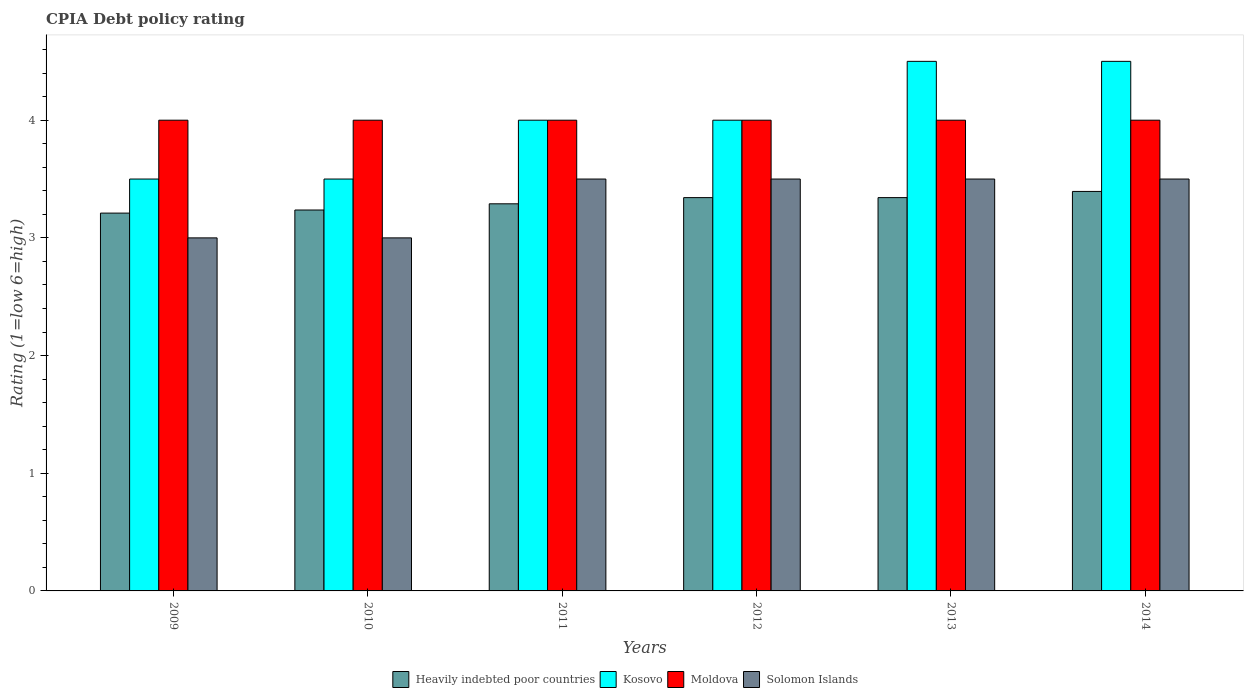How many different coloured bars are there?
Provide a succinct answer. 4. Are the number of bars on each tick of the X-axis equal?
Ensure brevity in your answer.  Yes. What is the label of the 3rd group of bars from the left?
Your answer should be very brief. 2011. What is the CPIA rating in Heavily indebted poor countries in 2014?
Offer a very short reply. 3.39. Across all years, what is the maximum CPIA rating in Moldova?
Make the answer very short. 4. In which year was the CPIA rating in Solomon Islands maximum?
Offer a very short reply. 2011. What is the total CPIA rating in Heavily indebted poor countries in the graph?
Ensure brevity in your answer.  19.82. What is the difference between the CPIA rating in Moldova in 2010 and the CPIA rating in Kosovo in 2012?
Your answer should be compact. 0. What is the average CPIA rating in Solomon Islands per year?
Keep it short and to the point. 3.33. What is the ratio of the CPIA rating in Heavily indebted poor countries in 2009 to that in 2010?
Your answer should be very brief. 0.99. Is the CPIA rating in Moldova in 2010 less than that in 2013?
Provide a succinct answer. No. What is the difference between the highest and the second highest CPIA rating in Moldova?
Provide a succinct answer. 0. What is the difference between the highest and the lowest CPIA rating in Solomon Islands?
Offer a terse response. 0.5. In how many years, is the CPIA rating in Kosovo greater than the average CPIA rating in Kosovo taken over all years?
Provide a short and direct response. 2. Is the sum of the CPIA rating in Solomon Islands in 2009 and 2014 greater than the maximum CPIA rating in Kosovo across all years?
Offer a terse response. Yes. Is it the case that in every year, the sum of the CPIA rating in Solomon Islands and CPIA rating in Heavily indebted poor countries is greater than the sum of CPIA rating in Kosovo and CPIA rating in Moldova?
Your response must be concise. No. What does the 1st bar from the left in 2009 represents?
Offer a terse response. Heavily indebted poor countries. What does the 1st bar from the right in 2013 represents?
Your answer should be very brief. Solomon Islands. Is it the case that in every year, the sum of the CPIA rating in Solomon Islands and CPIA rating in Heavily indebted poor countries is greater than the CPIA rating in Kosovo?
Your answer should be compact. Yes. How many bars are there?
Offer a terse response. 24. Are all the bars in the graph horizontal?
Give a very brief answer. No. How many years are there in the graph?
Keep it short and to the point. 6. What is the difference between two consecutive major ticks on the Y-axis?
Keep it short and to the point. 1. Does the graph contain any zero values?
Provide a succinct answer. No. Where does the legend appear in the graph?
Make the answer very short. Bottom center. How many legend labels are there?
Provide a succinct answer. 4. What is the title of the graph?
Your answer should be compact. CPIA Debt policy rating. What is the label or title of the Y-axis?
Offer a very short reply. Rating (1=low 6=high). What is the Rating (1=low 6=high) in Heavily indebted poor countries in 2009?
Your answer should be compact. 3.21. What is the Rating (1=low 6=high) of Moldova in 2009?
Your response must be concise. 4. What is the Rating (1=low 6=high) in Heavily indebted poor countries in 2010?
Offer a terse response. 3.24. What is the Rating (1=low 6=high) of Kosovo in 2010?
Offer a terse response. 3.5. What is the Rating (1=low 6=high) in Solomon Islands in 2010?
Offer a terse response. 3. What is the Rating (1=low 6=high) of Heavily indebted poor countries in 2011?
Give a very brief answer. 3.29. What is the Rating (1=low 6=high) in Solomon Islands in 2011?
Your answer should be compact. 3.5. What is the Rating (1=low 6=high) of Heavily indebted poor countries in 2012?
Give a very brief answer. 3.34. What is the Rating (1=low 6=high) of Solomon Islands in 2012?
Offer a very short reply. 3.5. What is the Rating (1=low 6=high) of Heavily indebted poor countries in 2013?
Provide a short and direct response. 3.34. What is the Rating (1=low 6=high) of Heavily indebted poor countries in 2014?
Give a very brief answer. 3.39. What is the Rating (1=low 6=high) in Moldova in 2014?
Offer a terse response. 4. What is the Rating (1=low 6=high) of Solomon Islands in 2014?
Keep it short and to the point. 3.5. Across all years, what is the maximum Rating (1=low 6=high) in Heavily indebted poor countries?
Your response must be concise. 3.39. Across all years, what is the maximum Rating (1=low 6=high) in Kosovo?
Keep it short and to the point. 4.5. Across all years, what is the maximum Rating (1=low 6=high) of Solomon Islands?
Ensure brevity in your answer.  3.5. Across all years, what is the minimum Rating (1=low 6=high) of Heavily indebted poor countries?
Keep it short and to the point. 3.21. What is the total Rating (1=low 6=high) in Heavily indebted poor countries in the graph?
Offer a terse response. 19.82. What is the total Rating (1=low 6=high) of Solomon Islands in the graph?
Make the answer very short. 20. What is the difference between the Rating (1=low 6=high) of Heavily indebted poor countries in 2009 and that in 2010?
Offer a very short reply. -0.03. What is the difference between the Rating (1=low 6=high) of Kosovo in 2009 and that in 2010?
Your answer should be compact. 0. What is the difference between the Rating (1=low 6=high) of Moldova in 2009 and that in 2010?
Keep it short and to the point. 0. What is the difference between the Rating (1=low 6=high) in Heavily indebted poor countries in 2009 and that in 2011?
Keep it short and to the point. -0.08. What is the difference between the Rating (1=low 6=high) in Moldova in 2009 and that in 2011?
Give a very brief answer. 0. What is the difference between the Rating (1=low 6=high) in Heavily indebted poor countries in 2009 and that in 2012?
Give a very brief answer. -0.13. What is the difference between the Rating (1=low 6=high) in Solomon Islands in 2009 and that in 2012?
Your answer should be very brief. -0.5. What is the difference between the Rating (1=low 6=high) in Heavily indebted poor countries in 2009 and that in 2013?
Your answer should be very brief. -0.13. What is the difference between the Rating (1=low 6=high) in Moldova in 2009 and that in 2013?
Your response must be concise. 0. What is the difference between the Rating (1=low 6=high) of Solomon Islands in 2009 and that in 2013?
Make the answer very short. -0.5. What is the difference between the Rating (1=low 6=high) in Heavily indebted poor countries in 2009 and that in 2014?
Provide a short and direct response. -0.18. What is the difference between the Rating (1=low 6=high) in Solomon Islands in 2009 and that in 2014?
Your response must be concise. -0.5. What is the difference between the Rating (1=low 6=high) in Heavily indebted poor countries in 2010 and that in 2011?
Provide a succinct answer. -0.05. What is the difference between the Rating (1=low 6=high) in Kosovo in 2010 and that in 2011?
Give a very brief answer. -0.5. What is the difference between the Rating (1=low 6=high) of Heavily indebted poor countries in 2010 and that in 2012?
Ensure brevity in your answer.  -0.11. What is the difference between the Rating (1=low 6=high) in Solomon Islands in 2010 and that in 2012?
Give a very brief answer. -0.5. What is the difference between the Rating (1=low 6=high) in Heavily indebted poor countries in 2010 and that in 2013?
Offer a very short reply. -0.11. What is the difference between the Rating (1=low 6=high) of Kosovo in 2010 and that in 2013?
Provide a succinct answer. -1. What is the difference between the Rating (1=low 6=high) in Heavily indebted poor countries in 2010 and that in 2014?
Make the answer very short. -0.16. What is the difference between the Rating (1=low 6=high) in Kosovo in 2010 and that in 2014?
Offer a very short reply. -1. What is the difference between the Rating (1=low 6=high) in Moldova in 2010 and that in 2014?
Ensure brevity in your answer.  0. What is the difference between the Rating (1=low 6=high) of Solomon Islands in 2010 and that in 2014?
Provide a succinct answer. -0.5. What is the difference between the Rating (1=low 6=high) in Heavily indebted poor countries in 2011 and that in 2012?
Offer a very short reply. -0.05. What is the difference between the Rating (1=low 6=high) of Moldova in 2011 and that in 2012?
Your response must be concise. 0. What is the difference between the Rating (1=low 6=high) of Heavily indebted poor countries in 2011 and that in 2013?
Your answer should be very brief. -0.05. What is the difference between the Rating (1=low 6=high) of Kosovo in 2011 and that in 2013?
Offer a terse response. -0.5. What is the difference between the Rating (1=low 6=high) in Heavily indebted poor countries in 2011 and that in 2014?
Offer a terse response. -0.11. What is the difference between the Rating (1=low 6=high) of Kosovo in 2011 and that in 2014?
Keep it short and to the point. -0.5. What is the difference between the Rating (1=low 6=high) in Moldova in 2011 and that in 2014?
Provide a short and direct response. 0. What is the difference between the Rating (1=low 6=high) of Kosovo in 2012 and that in 2013?
Offer a terse response. -0.5. What is the difference between the Rating (1=low 6=high) of Heavily indebted poor countries in 2012 and that in 2014?
Make the answer very short. -0.05. What is the difference between the Rating (1=low 6=high) of Solomon Islands in 2012 and that in 2014?
Offer a very short reply. 0. What is the difference between the Rating (1=low 6=high) in Heavily indebted poor countries in 2013 and that in 2014?
Your answer should be very brief. -0.05. What is the difference between the Rating (1=low 6=high) in Moldova in 2013 and that in 2014?
Make the answer very short. 0. What is the difference between the Rating (1=low 6=high) in Solomon Islands in 2013 and that in 2014?
Your response must be concise. 0. What is the difference between the Rating (1=low 6=high) of Heavily indebted poor countries in 2009 and the Rating (1=low 6=high) of Kosovo in 2010?
Provide a succinct answer. -0.29. What is the difference between the Rating (1=low 6=high) in Heavily indebted poor countries in 2009 and the Rating (1=low 6=high) in Moldova in 2010?
Provide a succinct answer. -0.79. What is the difference between the Rating (1=low 6=high) of Heavily indebted poor countries in 2009 and the Rating (1=low 6=high) of Solomon Islands in 2010?
Your response must be concise. 0.21. What is the difference between the Rating (1=low 6=high) in Kosovo in 2009 and the Rating (1=low 6=high) in Solomon Islands in 2010?
Make the answer very short. 0.5. What is the difference between the Rating (1=low 6=high) in Moldova in 2009 and the Rating (1=low 6=high) in Solomon Islands in 2010?
Ensure brevity in your answer.  1. What is the difference between the Rating (1=low 6=high) of Heavily indebted poor countries in 2009 and the Rating (1=low 6=high) of Kosovo in 2011?
Offer a very short reply. -0.79. What is the difference between the Rating (1=low 6=high) in Heavily indebted poor countries in 2009 and the Rating (1=low 6=high) in Moldova in 2011?
Give a very brief answer. -0.79. What is the difference between the Rating (1=low 6=high) of Heavily indebted poor countries in 2009 and the Rating (1=low 6=high) of Solomon Islands in 2011?
Provide a succinct answer. -0.29. What is the difference between the Rating (1=low 6=high) of Kosovo in 2009 and the Rating (1=low 6=high) of Moldova in 2011?
Ensure brevity in your answer.  -0.5. What is the difference between the Rating (1=low 6=high) of Moldova in 2009 and the Rating (1=low 6=high) of Solomon Islands in 2011?
Provide a short and direct response. 0.5. What is the difference between the Rating (1=low 6=high) of Heavily indebted poor countries in 2009 and the Rating (1=low 6=high) of Kosovo in 2012?
Keep it short and to the point. -0.79. What is the difference between the Rating (1=low 6=high) in Heavily indebted poor countries in 2009 and the Rating (1=low 6=high) in Moldova in 2012?
Your answer should be compact. -0.79. What is the difference between the Rating (1=low 6=high) of Heavily indebted poor countries in 2009 and the Rating (1=low 6=high) of Solomon Islands in 2012?
Ensure brevity in your answer.  -0.29. What is the difference between the Rating (1=low 6=high) in Kosovo in 2009 and the Rating (1=low 6=high) in Moldova in 2012?
Give a very brief answer. -0.5. What is the difference between the Rating (1=low 6=high) in Heavily indebted poor countries in 2009 and the Rating (1=low 6=high) in Kosovo in 2013?
Ensure brevity in your answer.  -1.29. What is the difference between the Rating (1=low 6=high) of Heavily indebted poor countries in 2009 and the Rating (1=low 6=high) of Moldova in 2013?
Give a very brief answer. -0.79. What is the difference between the Rating (1=low 6=high) of Heavily indebted poor countries in 2009 and the Rating (1=low 6=high) of Solomon Islands in 2013?
Make the answer very short. -0.29. What is the difference between the Rating (1=low 6=high) in Kosovo in 2009 and the Rating (1=low 6=high) in Moldova in 2013?
Offer a very short reply. -0.5. What is the difference between the Rating (1=low 6=high) in Heavily indebted poor countries in 2009 and the Rating (1=low 6=high) in Kosovo in 2014?
Offer a terse response. -1.29. What is the difference between the Rating (1=low 6=high) of Heavily indebted poor countries in 2009 and the Rating (1=low 6=high) of Moldova in 2014?
Provide a succinct answer. -0.79. What is the difference between the Rating (1=low 6=high) of Heavily indebted poor countries in 2009 and the Rating (1=low 6=high) of Solomon Islands in 2014?
Keep it short and to the point. -0.29. What is the difference between the Rating (1=low 6=high) in Kosovo in 2009 and the Rating (1=low 6=high) in Moldova in 2014?
Offer a terse response. -0.5. What is the difference between the Rating (1=low 6=high) of Moldova in 2009 and the Rating (1=low 6=high) of Solomon Islands in 2014?
Your response must be concise. 0.5. What is the difference between the Rating (1=low 6=high) in Heavily indebted poor countries in 2010 and the Rating (1=low 6=high) in Kosovo in 2011?
Offer a very short reply. -0.76. What is the difference between the Rating (1=low 6=high) of Heavily indebted poor countries in 2010 and the Rating (1=low 6=high) of Moldova in 2011?
Provide a succinct answer. -0.76. What is the difference between the Rating (1=low 6=high) of Heavily indebted poor countries in 2010 and the Rating (1=low 6=high) of Solomon Islands in 2011?
Ensure brevity in your answer.  -0.26. What is the difference between the Rating (1=low 6=high) in Moldova in 2010 and the Rating (1=low 6=high) in Solomon Islands in 2011?
Make the answer very short. 0.5. What is the difference between the Rating (1=low 6=high) of Heavily indebted poor countries in 2010 and the Rating (1=low 6=high) of Kosovo in 2012?
Keep it short and to the point. -0.76. What is the difference between the Rating (1=low 6=high) in Heavily indebted poor countries in 2010 and the Rating (1=low 6=high) in Moldova in 2012?
Keep it short and to the point. -0.76. What is the difference between the Rating (1=low 6=high) of Heavily indebted poor countries in 2010 and the Rating (1=low 6=high) of Solomon Islands in 2012?
Provide a short and direct response. -0.26. What is the difference between the Rating (1=low 6=high) of Kosovo in 2010 and the Rating (1=low 6=high) of Moldova in 2012?
Make the answer very short. -0.5. What is the difference between the Rating (1=low 6=high) of Heavily indebted poor countries in 2010 and the Rating (1=low 6=high) of Kosovo in 2013?
Give a very brief answer. -1.26. What is the difference between the Rating (1=low 6=high) in Heavily indebted poor countries in 2010 and the Rating (1=low 6=high) in Moldova in 2013?
Your answer should be very brief. -0.76. What is the difference between the Rating (1=low 6=high) of Heavily indebted poor countries in 2010 and the Rating (1=low 6=high) of Solomon Islands in 2013?
Make the answer very short. -0.26. What is the difference between the Rating (1=low 6=high) of Kosovo in 2010 and the Rating (1=low 6=high) of Moldova in 2013?
Provide a short and direct response. -0.5. What is the difference between the Rating (1=low 6=high) of Moldova in 2010 and the Rating (1=low 6=high) of Solomon Islands in 2013?
Ensure brevity in your answer.  0.5. What is the difference between the Rating (1=low 6=high) of Heavily indebted poor countries in 2010 and the Rating (1=low 6=high) of Kosovo in 2014?
Your answer should be very brief. -1.26. What is the difference between the Rating (1=low 6=high) in Heavily indebted poor countries in 2010 and the Rating (1=low 6=high) in Moldova in 2014?
Offer a terse response. -0.76. What is the difference between the Rating (1=low 6=high) in Heavily indebted poor countries in 2010 and the Rating (1=low 6=high) in Solomon Islands in 2014?
Offer a very short reply. -0.26. What is the difference between the Rating (1=low 6=high) in Kosovo in 2010 and the Rating (1=low 6=high) in Moldova in 2014?
Make the answer very short. -0.5. What is the difference between the Rating (1=low 6=high) in Kosovo in 2010 and the Rating (1=low 6=high) in Solomon Islands in 2014?
Make the answer very short. 0. What is the difference between the Rating (1=low 6=high) of Heavily indebted poor countries in 2011 and the Rating (1=low 6=high) of Kosovo in 2012?
Keep it short and to the point. -0.71. What is the difference between the Rating (1=low 6=high) in Heavily indebted poor countries in 2011 and the Rating (1=low 6=high) in Moldova in 2012?
Your answer should be very brief. -0.71. What is the difference between the Rating (1=low 6=high) of Heavily indebted poor countries in 2011 and the Rating (1=low 6=high) of Solomon Islands in 2012?
Your answer should be very brief. -0.21. What is the difference between the Rating (1=low 6=high) of Moldova in 2011 and the Rating (1=low 6=high) of Solomon Islands in 2012?
Give a very brief answer. 0.5. What is the difference between the Rating (1=low 6=high) of Heavily indebted poor countries in 2011 and the Rating (1=low 6=high) of Kosovo in 2013?
Keep it short and to the point. -1.21. What is the difference between the Rating (1=low 6=high) in Heavily indebted poor countries in 2011 and the Rating (1=low 6=high) in Moldova in 2013?
Offer a terse response. -0.71. What is the difference between the Rating (1=low 6=high) of Heavily indebted poor countries in 2011 and the Rating (1=low 6=high) of Solomon Islands in 2013?
Ensure brevity in your answer.  -0.21. What is the difference between the Rating (1=low 6=high) in Kosovo in 2011 and the Rating (1=low 6=high) in Moldova in 2013?
Provide a short and direct response. 0. What is the difference between the Rating (1=low 6=high) of Moldova in 2011 and the Rating (1=low 6=high) of Solomon Islands in 2013?
Make the answer very short. 0.5. What is the difference between the Rating (1=low 6=high) of Heavily indebted poor countries in 2011 and the Rating (1=low 6=high) of Kosovo in 2014?
Your answer should be very brief. -1.21. What is the difference between the Rating (1=low 6=high) in Heavily indebted poor countries in 2011 and the Rating (1=low 6=high) in Moldova in 2014?
Provide a succinct answer. -0.71. What is the difference between the Rating (1=low 6=high) of Heavily indebted poor countries in 2011 and the Rating (1=low 6=high) of Solomon Islands in 2014?
Your answer should be compact. -0.21. What is the difference between the Rating (1=low 6=high) in Kosovo in 2011 and the Rating (1=low 6=high) in Solomon Islands in 2014?
Give a very brief answer. 0.5. What is the difference between the Rating (1=low 6=high) in Heavily indebted poor countries in 2012 and the Rating (1=low 6=high) in Kosovo in 2013?
Keep it short and to the point. -1.16. What is the difference between the Rating (1=low 6=high) of Heavily indebted poor countries in 2012 and the Rating (1=low 6=high) of Moldova in 2013?
Your answer should be compact. -0.66. What is the difference between the Rating (1=low 6=high) in Heavily indebted poor countries in 2012 and the Rating (1=low 6=high) in Solomon Islands in 2013?
Offer a very short reply. -0.16. What is the difference between the Rating (1=low 6=high) of Kosovo in 2012 and the Rating (1=low 6=high) of Solomon Islands in 2013?
Your response must be concise. 0.5. What is the difference between the Rating (1=low 6=high) in Moldova in 2012 and the Rating (1=low 6=high) in Solomon Islands in 2013?
Make the answer very short. 0.5. What is the difference between the Rating (1=low 6=high) in Heavily indebted poor countries in 2012 and the Rating (1=low 6=high) in Kosovo in 2014?
Ensure brevity in your answer.  -1.16. What is the difference between the Rating (1=low 6=high) of Heavily indebted poor countries in 2012 and the Rating (1=low 6=high) of Moldova in 2014?
Provide a succinct answer. -0.66. What is the difference between the Rating (1=low 6=high) in Heavily indebted poor countries in 2012 and the Rating (1=low 6=high) in Solomon Islands in 2014?
Provide a short and direct response. -0.16. What is the difference between the Rating (1=low 6=high) of Kosovo in 2012 and the Rating (1=low 6=high) of Moldova in 2014?
Ensure brevity in your answer.  0. What is the difference between the Rating (1=low 6=high) of Kosovo in 2012 and the Rating (1=low 6=high) of Solomon Islands in 2014?
Your response must be concise. 0.5. What is the difference between the Rating (1=low 6=high) in Moldova in 2012 and the Rating (1=low 6=high) in Solomon Islands in 2014?
Make the answer very short. 0.5. What is the difference between the Rating (1=low 6=high) of Heavily indebted poor countries in 2013 and the Rating (1=low 6=high) of Kosovo in 2014?
Keep it short and to the point. -1.16. What is the difference between the Rating (1=low 6=high) of Heavily indebted poor countries in 2013 and the Rating (1=low 6=high) of Moldova in 2014?
Ensure brevity in your answer.  -0.66. What is the difference between the Rating (1=low 6=high) in Heavily indebted poor countries in 2013 and the Rating (1=low 6=high) in Solomon Islands in 2014?
Give a very brief answer. -0.16. What is the difference between the Rating (1=low 6=high) of Kosovo in 2013 and the Rating (1=low 6=high) of Moldova in 2014?
Make the answer very short. 0.5. What is the average Rating (1=low 6=high) of Heavily indebted poor countries per year?
Keep it short and to the point. 3.3. What is the average Rating (1=low 6=high) of Moldova per year?
Your response must be concise. 4. In the year 2009, what is the difference between the Rating (1=low 6=high) in Heavily indebted poor countries and Rating (1=low 6=high) in Kosovo?
Give a very brief answer. -0.29. In the year 2009, what is the difference between the Rating (1=low 6=high) of Heavily indebted poor countries and Rating (1=low 6=high) of Moldova?
Offer a terse response. -0.79. In the year 2009, what is the difference between the Rating (1=low 6=high) in Heavily indebted poor countries and Rating (1=low 6=high) in Solomon Islands?
Your answer should be very brief. 0.21. In the year 2009, what is the difference between the Rating (1=low 6=high) of Kosovo and Rating (1=low 6=high) of Solomon Islands?
Offer a terse response. 0.5. In the year 2009, what is the difference between the Rating (1=low 6=high) of Moldova and Rating (1=low 6=high) of Solomon Islands?
Keep it short and to the point. 1. In the year 2010, what is the difference between the Rating (1=low 6=high) in Heavily indebted poor countries and Rating (1=low 6=high) in Kosovo?
Keep it short and to the point. -0.26. In the year 2010, what is the difference between the Rating (1=low 6=high) in Heavily indebted poor countries and Rating (1=low 6=high) in Moldova?
Your answer should be compact. -0.76. In the year 2010, what is the difference between the Rating (1=low 6=high) in Heavily indebted poor countries and Rating (1=low 6=high) in Solomon Islands?
Your answer should be compact. 0.24. In the year 2010, what is the difference between the Rating (1=low 6=high) in Moldova and Rating (1=low 6=high) in Solomon Islands?
Your answer should be very brief. 1. In the year 2011, what is the difference between the Rating (1=low 6=high) of Heavily indebted poor countries and Rating (1=low 6=high) of Kosovo?
Your answer should be very brief. -0.71. In the year 2011, what is the difference between the Rating (1=low 6=high) of Heavily indebted poor countries and Rating (1=low 6=high) of Moldova?
Offer a very short reply. -0.71. In the year 2011, what is the difference between the Rating (1=low 6=high) in Heavily indebted poor countries and Rating (1=low 6=high) in Solomon Islands?
Make the answer very short. -0.21. In the year 2011, what is the difference between the Rating (1=low 6=high) in Kosovo and Rating (1=low 6=high) in Moldova?
Ensure brevity in your answer.  0. In the year 2012, what is the difference between the Rating (1=low 6=high) in Heavily indebted poor countries and Rating (1=low 6=high) in Kosovo?
Offer a very short reply. -0.66. In the year 2012, what is the difference between the Rating (1=low 6=high) of Heavily indebted poor countries and Rating (1=low 6=high) of Moldova?
Provide a short and direct response. -0.66. In the year 2012, what is the difference between the Rating (1=low 6=high) of Heavily indebted poor countries and Rating (1=low 6=high) of Solomon Islands?
Offer a terse response. -0.16. In the year 2012, what is the difference between the Rating (1=low 6=high) of Kosovo and Rating (1=low 6=high) of Moldova?
Provide a short and direct response. 0. In the year 2012, what is the difference between the Rating (1=low 6=high) of Moldova and Rating (1=low 6=high) of Solomon Islands?
Provide a short and direct response. 0.5. In the year 2013, what is the difference between the Rating (1=low 6=high) in Heavily indebted poor countries and Rating (1=low 6=high) in Kosovo?
Provide a short and direct response. -1.16. In the year 2013, what is the difference between the Rating (1=low 6=high) in Heavily indebted poor countries and Rating (1=low 6=high) in Moldova?
Your response must be concise. -0.66. In the year 2013, what is the difference between the Rating (1=low 6=high) in Heavily indebted poor countries and Rating (1=low 6=high) in Solomon Islands?
Offer a very short reply. -0.16. In the year 2013, what is the difference between the Rating (1=low 6=high) in Kosovo and Rating (1=low 6=high) in Solomon Islands?
Ensure brevity in your answer.  1. In the year 2013, what is the difference between the Rating (1=low 6=high) in Moldova and Rating (1=low 6=high) in Solomon Islands?
Provide a short and direct response. 0.5. In the year 2014, what is the difference between the Rating (1=low 6=high) in Heavily indebted poor countries and Rating (1=low 6=high) in Kosovo?
Offer a terse response. -1.11. In the year 2014, what is the difference between the Rating (1=low 6=high) of Heavily indebted poor countries and Rating (1=low 6=high) of Moldova?
Your answer should be very brief. -0.61. In the year 2014, what is the difference between the Rating (1=low 6=high) of Heavily indebted poor countries and Rating (1=low 6=high) of Solomon Islands?
Provide a short and direct response. -0.11. In the year 2014, what is the difference between the Rating (1=low 6=high) in Moldova and Rating (1=low 6=high) in Solomon Islands?
Ensure brevity in your answer.  0.5. What is the ratio of the Rating (1=low 6=high) of Heavily indebted poor countries in 2009 to that in 2010?
Offer a terse response. 0.99. What is the ratio of the Rating (1=low 6=high) in Moldova in 2009 to that in 2010?
Keep it short and to the point. 1. What is the ratio of the Rating (1=low 6=high) in Solomon Islands in 2009 to that in 2010?
Give a very brief answer. 1. What is the ratio of the Rating (1=low 6=high) of Heavily indebted poor countries in 2009 to that in 2011?
Ensure brevity in your answer.  0.98. What is the ratio of the Rating (1=low 6=high) in Kosovo in 2009 to that in 2011?
Your answer should be very brief. 0.88. What is the ratio of the Rating (1=low 6=high) of Solomon Islands in 2009 to that in 2011?
Make the answer very short. 0.86. What is the ratio of the Rating (1=low 6=high) of Heavily indebted poor countries in 2009 to that in 2012?
Provide a short and direct response. 0.96. What is the ratio of the Rating (1=low 6=high) of Heavily indebted poor countries in 2009 to that in 2013?
Your answer should be very brief. 0.96. What is the ratio of the Rating (1=low 6=high) of Kosovo in 2009 to that in 2013?
Offer a terse response. 0.78. What is the ratio of the Rating (1=low 6=high) in Moldova in 2009 to that in 2013?
Your answer should be compact. 1. What is the ratio of the Rating (1=low 6=high) in Solomon Islands in 2009 to that in 2013?
Provide a short and direct response. 0.86. What is the ratio of the Rating (1=low 6=high) of Heavily indebted poor countries in 2009 to that in 2014?
Your answer should be very brief. 0.95. What is the ratio of the Rating (1=low 6=high) in Heavily indebted poor countries in 2010 to that in 2011?
Keep it short and to the point. 0.98. What is the ratio of the Rating (1=low 6=high) in Kosovo in 2010 to that in 2011?
Ensure brevity in your answer.  0.88. What is the ratio of the Rating (1=low 6=high) in Moldova in 2010 to that in 2011?
Give a very brief answer. 1. What is the ratio of the Rating (1=low 6=high) of Heavily indebted poor countries in 2010 to that in 2012?
Give a very brief answer. 0.97. What is the ratio of the Rating (1=low 6=high) of Moldova in 2010 to that in 2012?
Keep it short and to the point. 1. What is the ratio of the Rating (1=low 6=high) of Heavily indebted poor countries in 2010 to that in 2013?
Your answer should be compact. 0.97. What is the ratio of the Rating (1=low 6=high) of Kosovo in 2010 to that in 2013?
Ensure brevity in your answer.  0.78. What is the ratio of the Rating (1=low 6=high) in Heavily indebted poor countries in 2010 to that in 2014?
Give a very brief answer. 0.95. What is the ratio of the Rating (1=low 6=high) of Moldova in 2010 to that in 2014?
Provide a short and direct response. 1. What is the ratio of the Rating (1=low 6=high) in Solomon Islands in 2010 to that in 2014?
Your response must be concise. 0.86. What is the ratio of the Rating (1=low 6=high) in Heavily indebted poor countries in 2011 to that in 2012?
Ensure brevity in your answer.  0.98. What is the ratio of the Rating (1=low 6=high) of Kosovo in 2011 to that in 2012?
Your answer should be compact. 1. What is the ratio of the Rating (1=low 6=high) of Solomon Islands in 2011 to that in 2012?
Offer a terse response. 1. What is the ratio of the Rating (1=low 6=high) in Heavily indebted poor countries in 2011 to that in 2013?
Your response must be concise. 0.98. What is the ratio of the Rating (1=low 6=high) of Moldova in 2011 to that in 2013?
Ensure brevity in your answer.  1. What is the ratio of the Rating (1=low 6=high) in Solomon Islands in 2011 to that in 2013?
Provide a succinct answer. 1. What is the ratio of the Rating (1=low 6=high) in Kosovo in 2011 to that in 2014?
Make the answer very short. 0.89. What is the ratio of the Rating (1=low 6=high) in Solomon Islands in 2011 to that in 2014?
Offer a terse response. 1. What is the ratio of the Rating (1=low 6=high) in Solomon Islands in 2012 to that in 2013?
Provide a succinct answer. 1. What is the ratio of the Rating (1=low 6=high) of Heavily indebted poor countries in 2012 to that in 2014?
Provide a short and direct response. 0.98. What is the ratio of the Rating (1=low 6=high) of Moldova in 2012 to that in 2014?
Ensure brevity in your answer.  1. What is the ratio of the Rating (1=low 6=high) in Heavily indebted poor countries in 2013 to that in 2014?
Your response must be concise. 0.98. What is the ratio of the Rating (1=low 6=high) of Kosovo in 2013 to that in 2014?
Offer a terse response. 1. What is the difference between the highest and the second highest Rating (1=low 6=high) in Heavily indebted poor countries?
Your answer should be very brief. 0.05. What is the difference between the highest and the second highest Rating (1=low 6=high) in Kosovo?
Provide a short and direct response. 0. What is the difference between the highest and the lowest Rating (1=low 6=high) of Heavily indebted poor countries?
Your answer should be very brief. 0.18. What is the difference between the highest and the lowest Rating (1=low 6=high) of Kosovo?
Provide a succinct answer. 1. What is the difference between the highest and the lowest Rating (1=low 6=high) in Moldova?
Your answer should be very brief. 0. What is the difference between the highest and the lowest Rating (1=low 6=high) of Solomon Islands?
Offer a terse response. 0.5. 